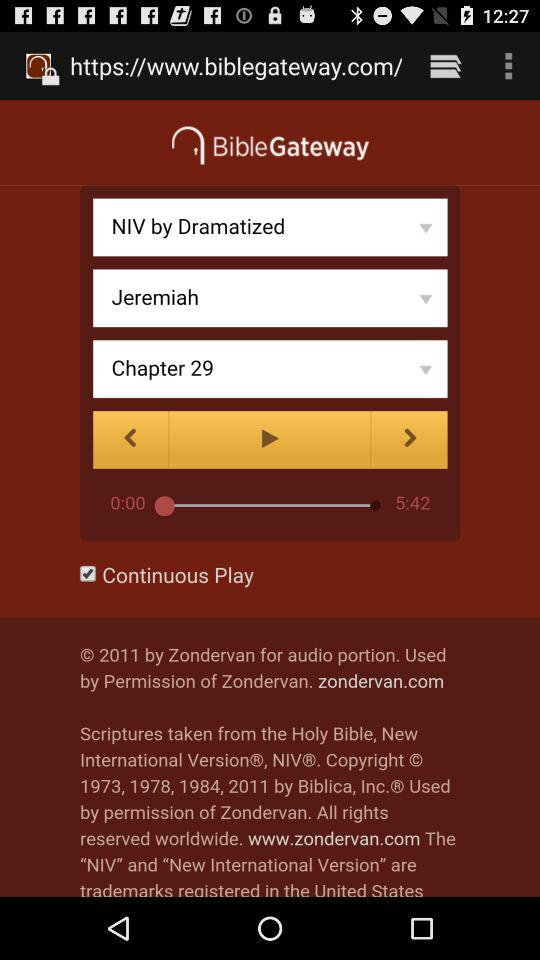What is the status of "Continuous Play"? The status is "on". 